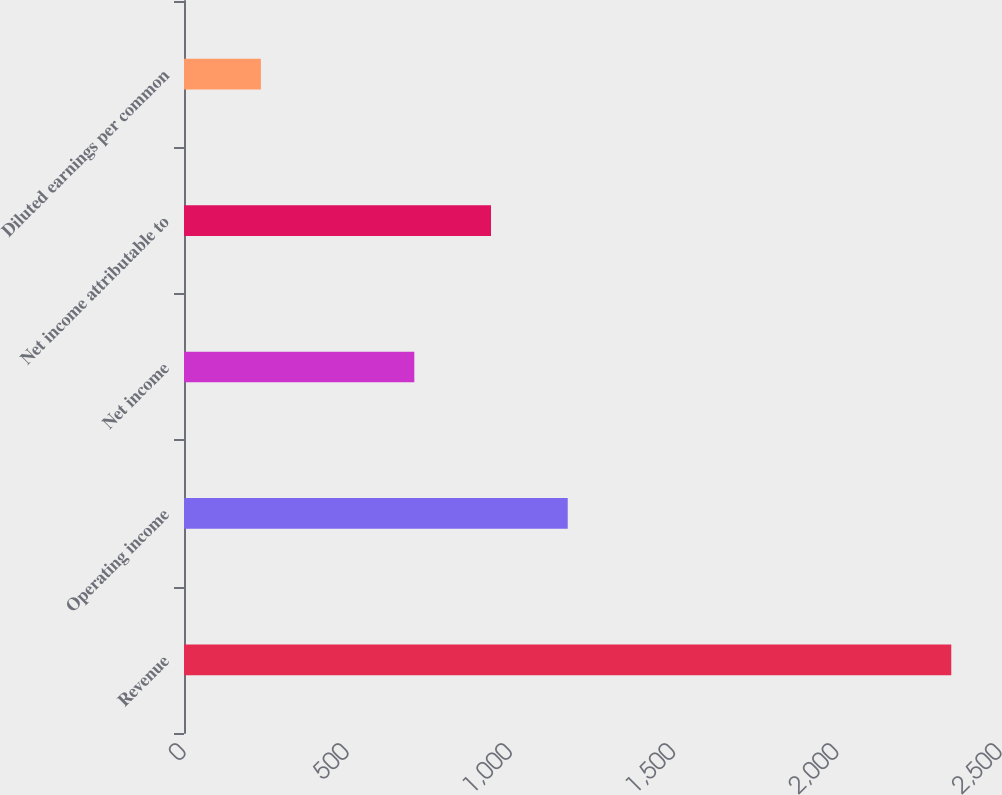<chart> <loc_0><loc_0><loc_500><loc_500><bar_chart><fcel>Revenue<fcel>Operating income<fcel>Net income<fcel>Net income attributable to<fcel>Diluted earnings per common<nl><fcel>2350.7<fcel>1175.62<fcel>705.58<fcel>940.6<fcel>235.54<nl></chart> 